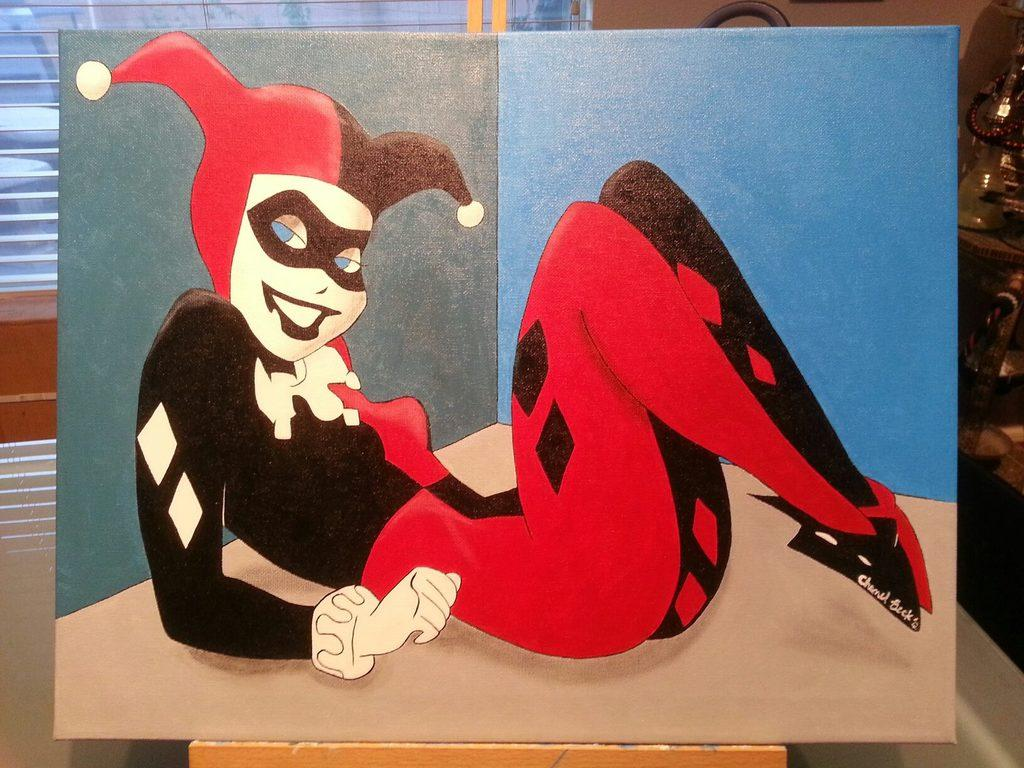What type of artwork is on the board in the image? There is a cartoon painting on the board in the image. What can be seen on the right side of the image? There are objects on the right side of the image. What is visible in the background of the image? There appears to be a window in the background of the image. Reasoning: Let's think step by step by step in order to produce the conversation. We start by identifying the main subject in the image, which is the cartoon painting on the board. Then, we expand the conversation to include other elements in the image, such as the objects on the right side and the window in the background. Each question is designed to elicit a specific detail about the image that is known from the provided facts. Absurd Question/Answer: How many bears are visible in the image? There are no bears present in the image. What type of army is depicted in the image? There is no army depicted in the image. How many bears are visible in the image? There are no bears present in the image. What type of army is depicted in the image? There is no army depicted in the image. 